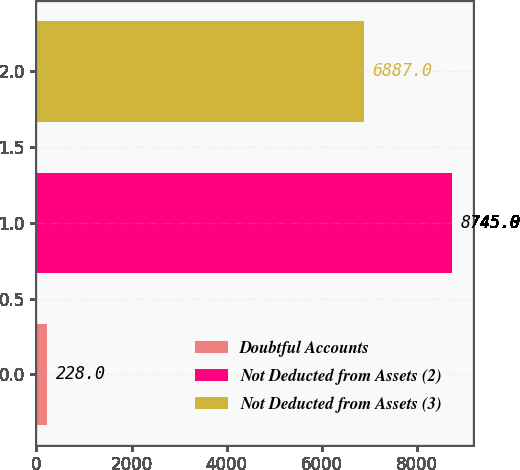Convert chart. <chart><loc_0><loc_0><loc_500><loc_500><bar_chart><fcel>Doubtful Accounts<fcel>Not Deducted from Assets (2)<fcel>Not Deducted from Assets (3)<nl><fcel>228<fcel>8745<fcel>6887<nl></chart> 